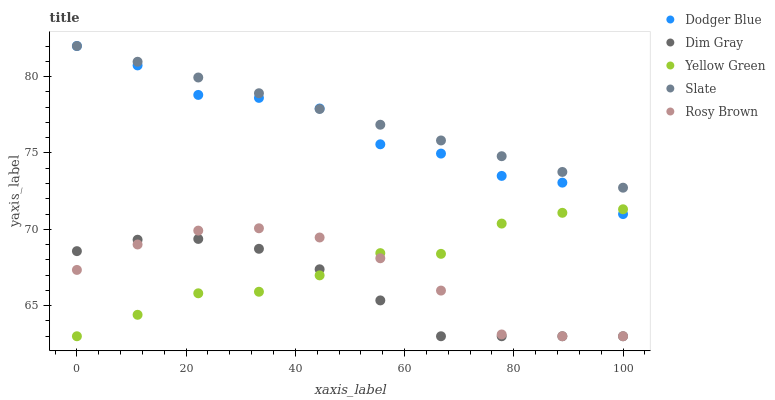Does Dim Gray have the minimum area under the curve?
Answer yes or no. Yes. Does Slate have the maximum area under the curve?
Answer yes or no. Yes. Does Dodger Blue have the minimum area under the curve?
Answer yes or no. No. Does Dodger Blue have the maximum area under the curve?
Answer yes or no. No. Is Slate the smoothest?
Answer yes or no. Yes. Is Dodger Blue the roughest?
Answer yes or no. Yes. Is Dim Gray the smoothest?
Answer yes or no. No. Is Dim Gray the roughest?
Answer yes or no. No. Does Dim Gray have the lowest value?
Answer yes or no. Yes. Does Dodger Blue have the lowest value?
Answer yes or no. No. Does Dodger Blue have the highest value?
Answer yes or no. Yes. Does Dim Gray have the highest value?
Answer yes or no. No. Is Yellow Green less than Slate?
Answer yes or no. Yes. Is Dodger Blue greater than Rosy Brown?
Answer yes or no. Yes. Does Dodger Blue intersect Yellow Green?
Answer yes or no. Yes. Is Dodger Blue less than Yellow Green?
Answer yes or no. No. Is Dodger Blue greater than Yellow Green?
Answer yes or no. No. Does Yellow Green intersect Slate?
Answer yes or no. No. 